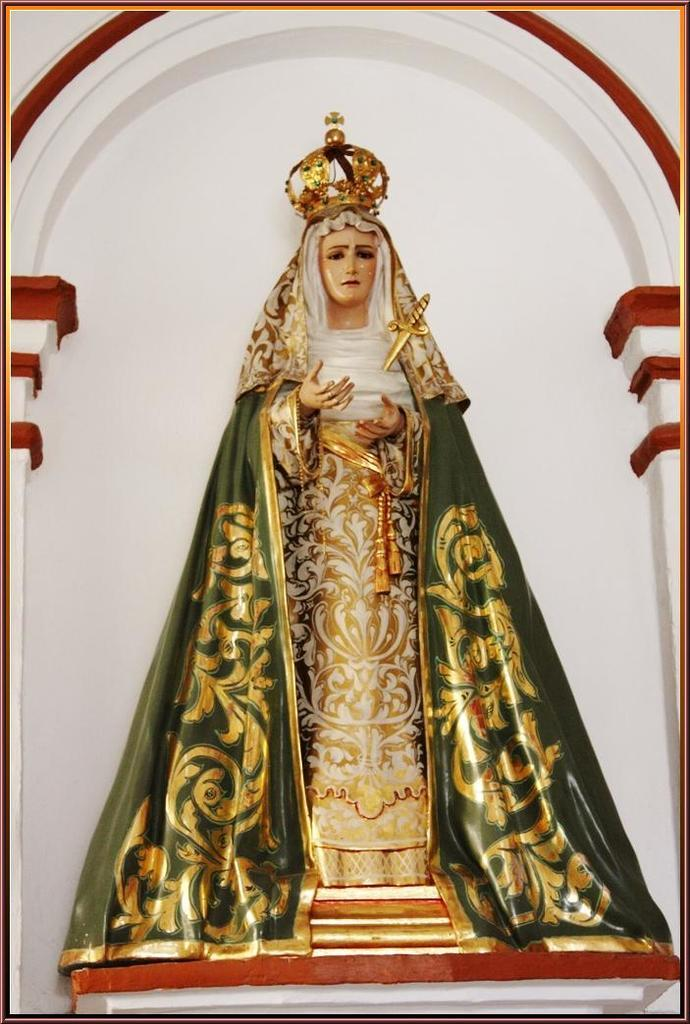What is the main subject in the middle of the image? There is a statue of a woman in the middle of the image. What can be seen in the background of the image? There is a wall in the background of the image. What type of beetle can be seen crawling on the statue in the image? There is no beetle present on the statue in the image. What color is the paint used on the statue in the image? The facts provided do not mention the color of the paint used on the statue. What emotion is the statue expressing in the image? The facts provided do not mention the emotion expressed by the statue. 